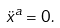Convert formula to latex. <formula><loc_0><loc_0><loc_500><loc_500>\ddot { x } ^ { a } = 0 .</formula> 